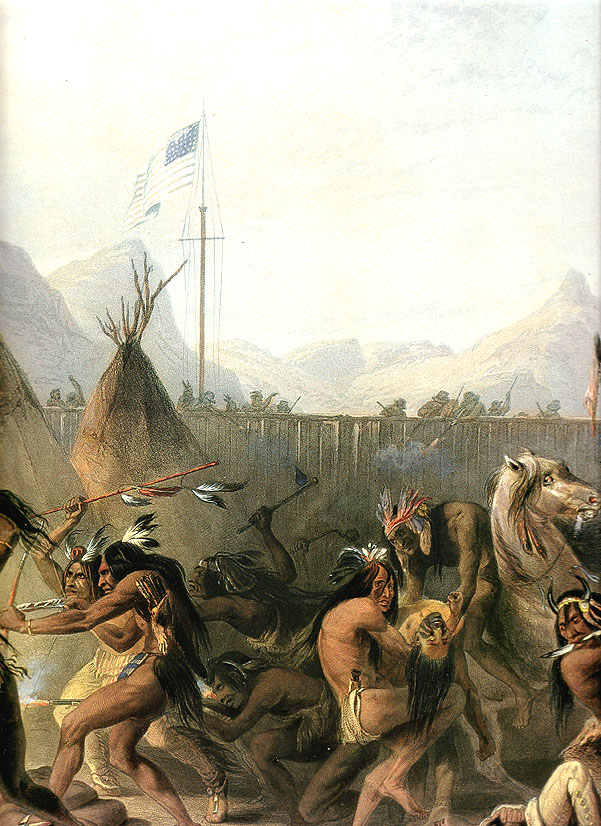Can you bring the scene to life with an imaginative retelling? As the sun began to dip behind the majestic mountains, casting long shadows across the encampment, the air crackled with anticipation. A drum began to beat, slow and steady, its sound resonating through the ground and up into the hearts of the people gathered. One by one, figures emerged, moving to the rhythm, their attire adorned with feathers and beads that shimmered in the golden light. The tribe had come together to celebrate the successful negotiation of peace with the settlers, symbolized by the American flag waving gently in the evening breeze. Children laughed and played on the periphery, while elders looked on, their faces lined with the stories of the past. Nearby, horses stood calm, as if knowing the significance of the moment. The dance circle formed, a living mosaic of motion and tradition, each step a tribute to their ancestors and a hopeful leap towards the future. As the tempo of the drum quickened, so did the dancers' movements, creating a whirlwind of color and sound. It was not just a dance; it was a living narrative, an assertion of their identity, strength, and spirit in a changing world. The painting captures this vibrant amalgam of tradition and change, providing a window into a moment where history, hope, and heartfelt expression converge. 